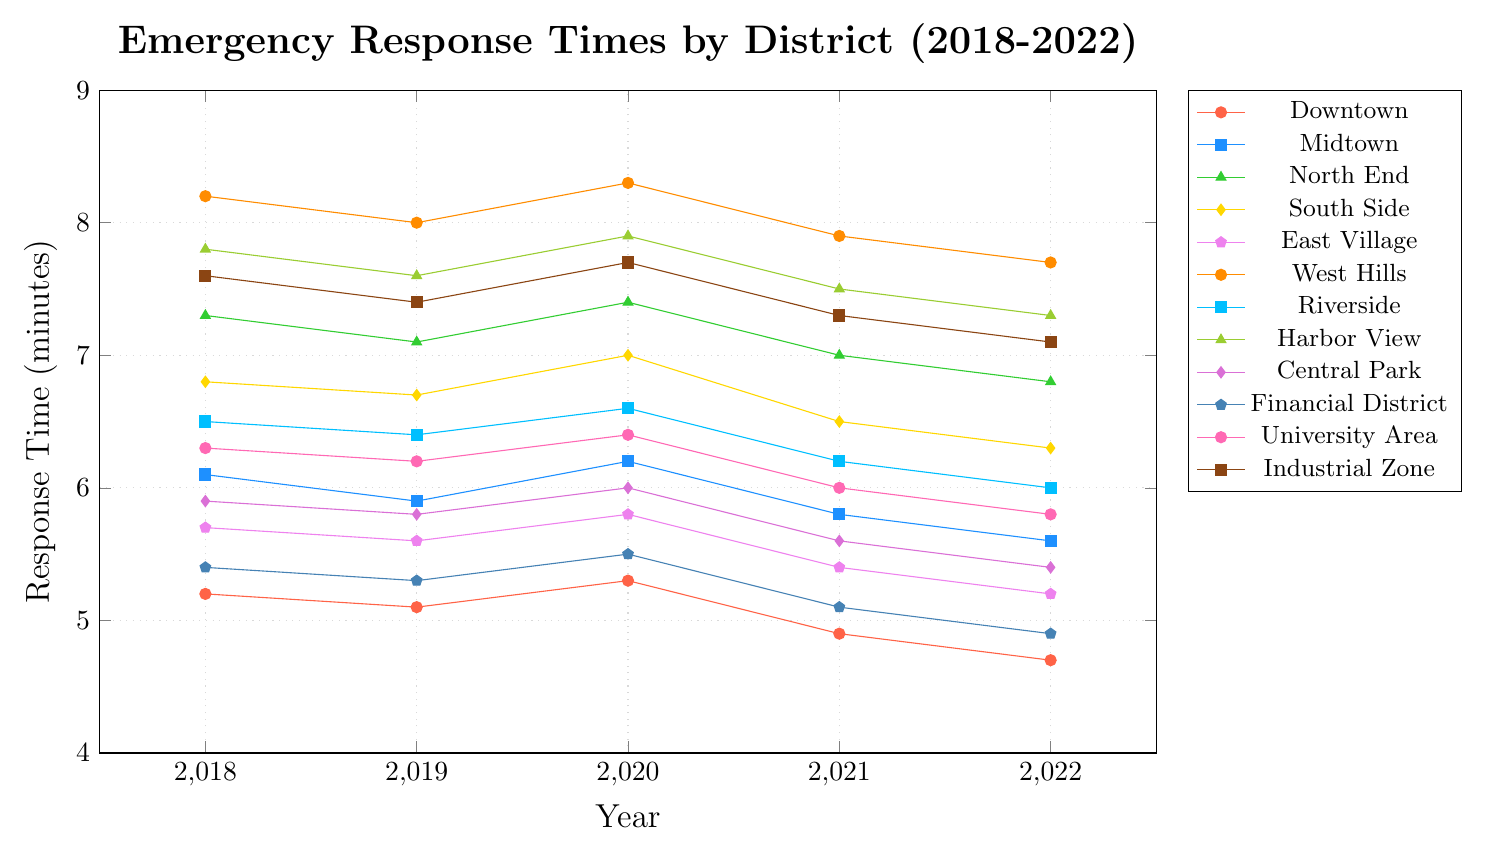What is the average response time for Downtown across the years? Sum the response times for Downtown over the years: (5.2 + 5.1 + 5.3 + 4.9 + 4.7) = 25.2, then divide by the number of years (5) to get the average: 25.2 / 5 = 5.04
Answer: 5.04 Which district has the highest response time in 2022? Compare the response times for each district in 2022. West Hills has the highest response time at 7.7 minutes.
Answer: West Hills Has the response time for Midtown increased or decreased from 2018 to 2022? Compare the response time for Midtown in 2018 (6.1) and 2022 (5.6). The response time has decreased.
Answer: Decreased Which two districts have the smallest difference in response times in 2022? Calculate the differences in response times in 2022 for all pairs of districts. The smallest difference is between Downtown (4.7) and Financial District (4.9), with a difference of 0.2 minutes.
Answer: Downtown and Financial District Between North End and Riverside, which district showed a greater improvement from 2018 to 2022? Calculate the improvement for North End: 7.3 - 6.8 = 0.5. Calculate the improvement for Riverside: 6.5 - 6.0 = 0.5. Both districts showed equal improvement.
Answer: Equal improvement What is the combined response time of South Side and Industrial Zone in 2022? Add the response times for South Side (6.3) and Industrial Zone (7.1) in 2022. The combined response time is 6.3 + 7.1 = 13.4 minutes.
Answer: 13.4 Identify the district with the most visually noticeable improvement in response times between 2020 and 2021. Compare the changes in response times from 2020 to 2021 for each district. Downtown's response time decreased from 5.3 to 4.9, the most noticeable improvement of 0.4 minutes.
Answer: Downtown Which color represents the University Area in the plot? The University Area is shown in pink color.
Answer: Pink What is the trend in response times for East Village from 2018 to 2022? Observing the values from 2018 to 2022 for East Village: 5.7, 5.6, 5.8, 5.4, 5.2, it shows a decreasing trend.
Answer: Decreasing For the year 2020, list the districts in ascending order of their response times. Sort the 2020 response times: Downtown (5.3), Financial District (5.5), East Village (5.8), Central Park (6.0), Midtown (6.2), University Area (6.4), Riverside (6.6), South Side (7.0), North End (7.4), Industrial Zone (7.7), Harbor View (7.9), West Hills (8.3).
Answer: Downtown, Financial District, East Village, Central Park, Midtown, University Area, Riverside, South Side, North End, Industrial Zone, Harbor View, West Hills 